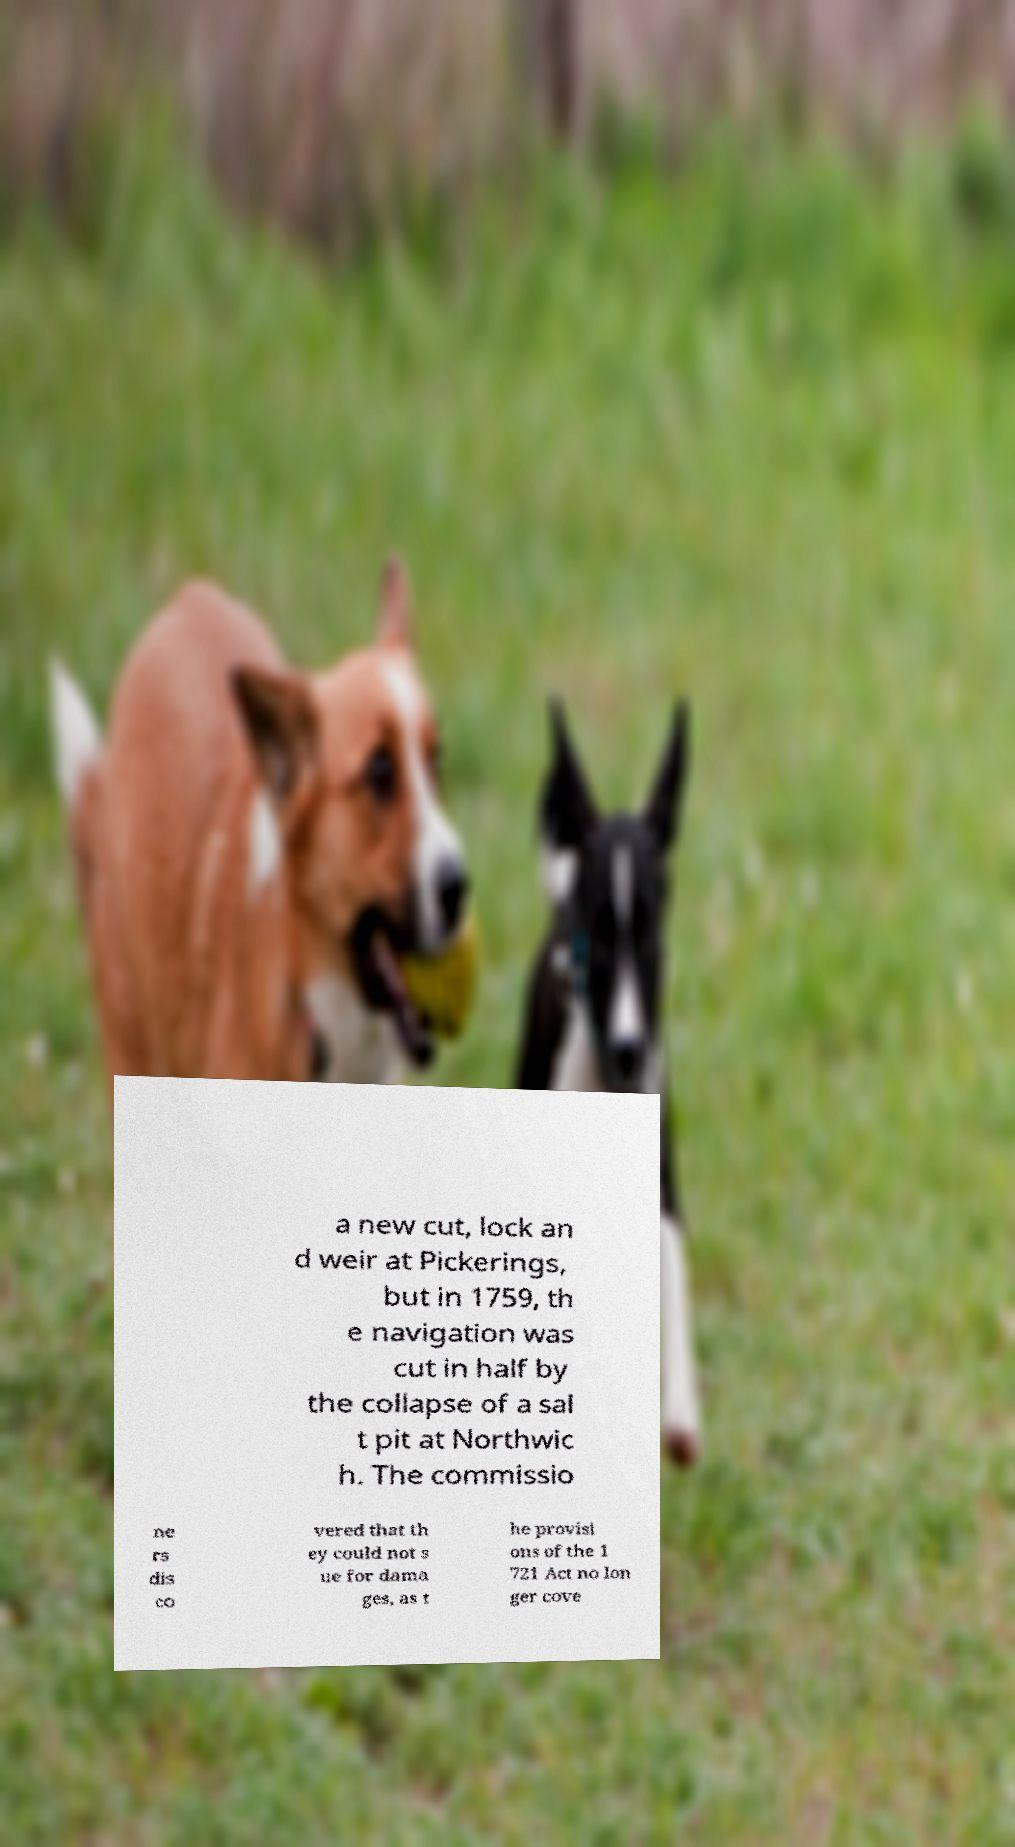I need the written content from this picture converted into text. Can you do that? a new cut, lock an d weir at Pickerings, but in 1759, th e navigation was cut in half by the collapse of a sal t pit at Northwic h. The commissio ne rs dis co vered that th ey could not s ue for dama ges, as t he provisi ons of the 1 721 Act no lon ger cove 